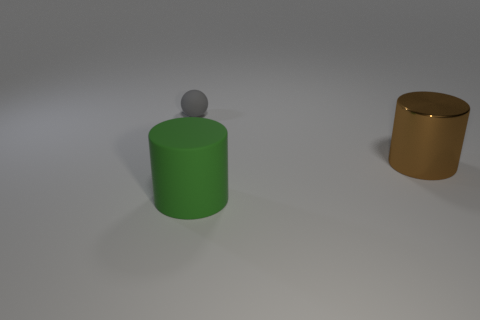Is the shape of the matte thing right of the sphere the same as  the gray matte thing?
Offer a terse response. No. Is the number of matte balls that are in front of the big metallic thing greater than the number of big blue metal cylinders?
Provide a succinct answer. No. Does the matte object behind the brown cylinder have the same color as the large metallic thing?
Provide a succinct answer. No. Is there anything else that is the same color as the tiny matte sphere?
Ensure brevity in your answer.  No. What color is the cylinder that is to the left of the large cylinder that is behind the rubber thing in front of the ball?
Offer a terse response. Green. Do the green cylinder and the gray ball have the same size?
Give a very brief answer. No. How many other green rubber cylinders have the same size as the green rubber cylinder?
Give a very brief answer. 0. Does the object to the left of the large rubber thing have the same material as the cylinder that is in front of the metallic object?
Offer a very short reply. Yes. Are there any other things that are the same shape as the big rubber thing?
Offer a terse response. Yes. The large metallic cylinder has what color?
Your answer should be very brief. Brown. 